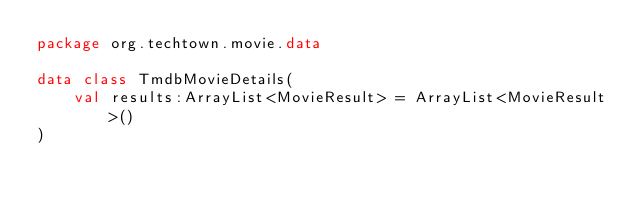Convert code to text. <code><loc_0><loc_0><loc_500><loc_500><_Kotlin_>package org.techtown.movie.data

data class TmdbMovieDetails(
    val results:ArrayList<MovieResult> = ArrayList<MovieResult>()
)</code> 